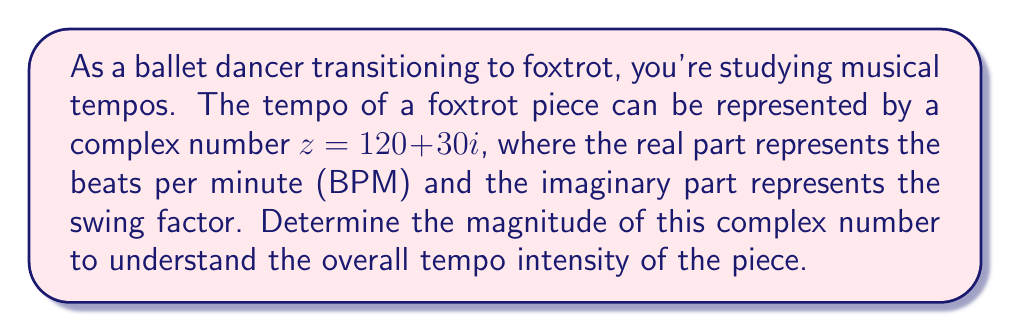Give your solution to this math problem. To find the magnitude of a complex number, we use the formula:

$$|z| = \sqrt{a^2 + b^2}$$

Where $a$ is the real part and $b$ is the imaginary part of the complex number $z = a + bi$.

In this case, we have $z = 120 + 30i$, so:

$a = 120$ (representing the BPM)
$b = 30$ (representing the swing factor)

Let's substitute these values into the formula:

$$|z| = \sqrt{120^2 + 30^2}$$

Now, let's calculate:

$$|z| = \sqrt{14400 + 900}$$
$$|z| = \sqrt{15300}$$
$$|z| = 123.69$$ (rounded to two decimal places)

This magnitude represents the overall tempo intensity of the foxtrot piece, combining both the basic tempo (BPM) and the swing factor.
Answer: $|z| = 123.69$ (rounded to two decimal places) 